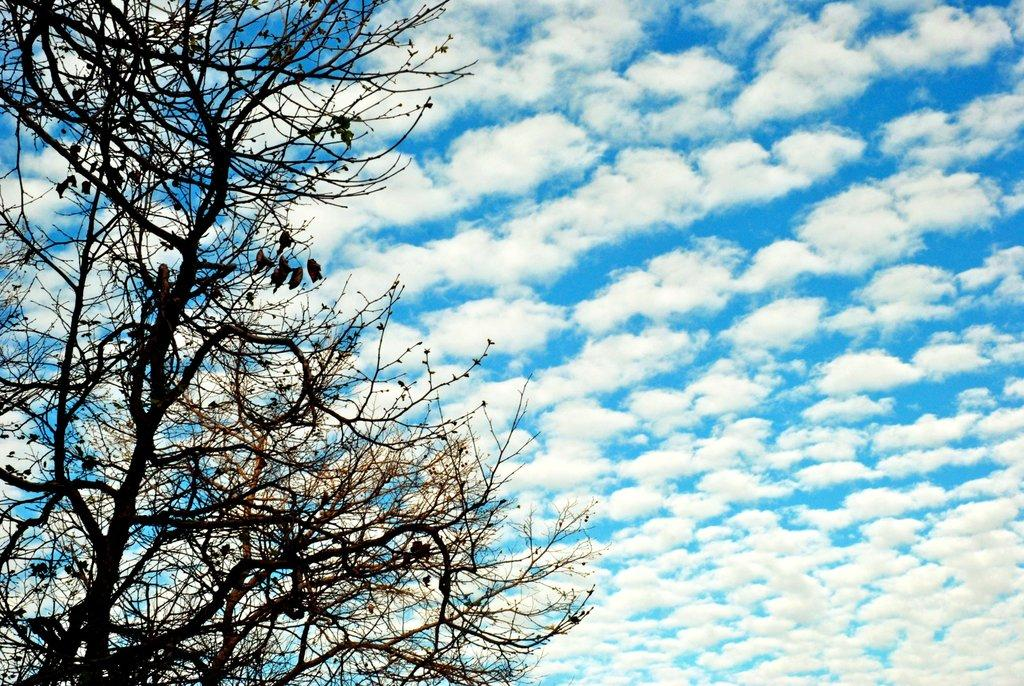What type of vegetation can be seen in the image? There are trees in the image. How would you describe the sky in the image? The sky is blue and cloudy in the image. How many flowers are on the shelf in the image? There is no shelf or flowers present in the image. What type of bird can be seen perched on the tree in the image? There is no bird, specifically a wren, present in the image. 